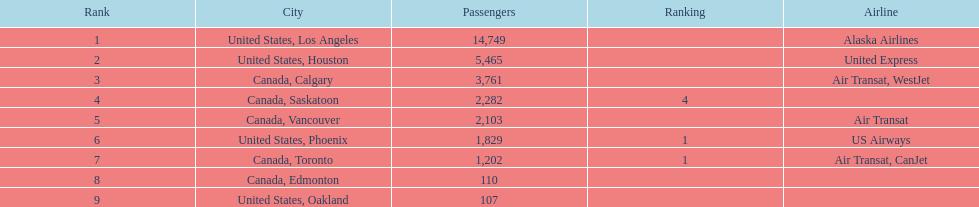In addition to los angeles, which city also contributed to a combined passenger count of around 19,000? Canada, Calgary. Could you help me parse every detail presented in this table? {'header': ['Rank', 'City', 'Passengers', 'Ranking', 'Airline'], 'rows': [['1', 'United States, Los Angeles', '14,749', '', 'Alaska Airlines'], ['2', 'United States, Houston', '5,465', '', 'United Express'], ['3', 'Canada, Calgary', '3,761', '', 'Air Transat, WestJet'], ['4', 'Canada, Saskatoon', '2,282', '4', ''], ['5', 'Canada, Vancouver', '2,103', '', 'Air Transat'], ['6', 'United States, Phoenix', '1,829', '1', 'US Airways'], ['7', 'Canada, Toronto', '1,202', '1', 'Air Transat, CanJet'], ['8', 'Canada, Edmonton', '110', '', ''], ['9', 'United States, Oakland', '107', '', '']]} 